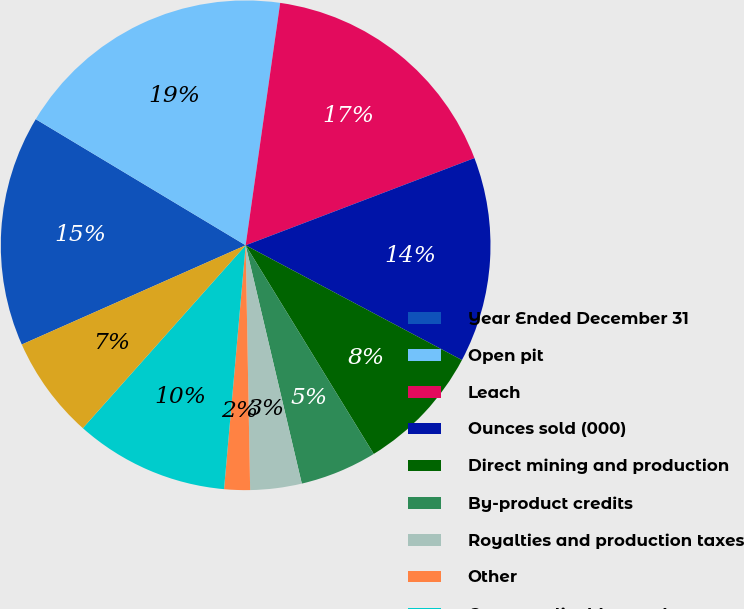<chart> <loc_0><loc_0><loc_500><loc_500><pie_chart><fcel>Year Ended December 31<fcel>Open pit<fcel>Leach<fcel>Ounces sold (000)<fcel>Direct mining and production<fcel>By-product credits<fcel>Royalties and production taxes<fcel>Other<fcel>Costs applicable to sales<fcel>Amortization<nl><fcel>15.25%<fcel>18.64%<fcel>16.95%<fcel>13.56%<fcel>8.47%<fcel>5.08%<fcel>3.39%<fcel>1.7%<fcel>10.17%<fcel>6.78%<nl></chart> 